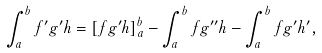Convert formula to latex. <formula><loc_0><loc_0><loc_500><loc_500>\int _ { a } ^ { b } f ^ { \prime } g ^ { \prime } h = [ f g ^ { \prime } h ] _ { a } ^ { b } - \int _ { a } ^ { b } f g ^ { \prime \prime } h - \int _ { a } ^ { b } f g ^ { \prime } h ^ { \prime } ,</formula> 